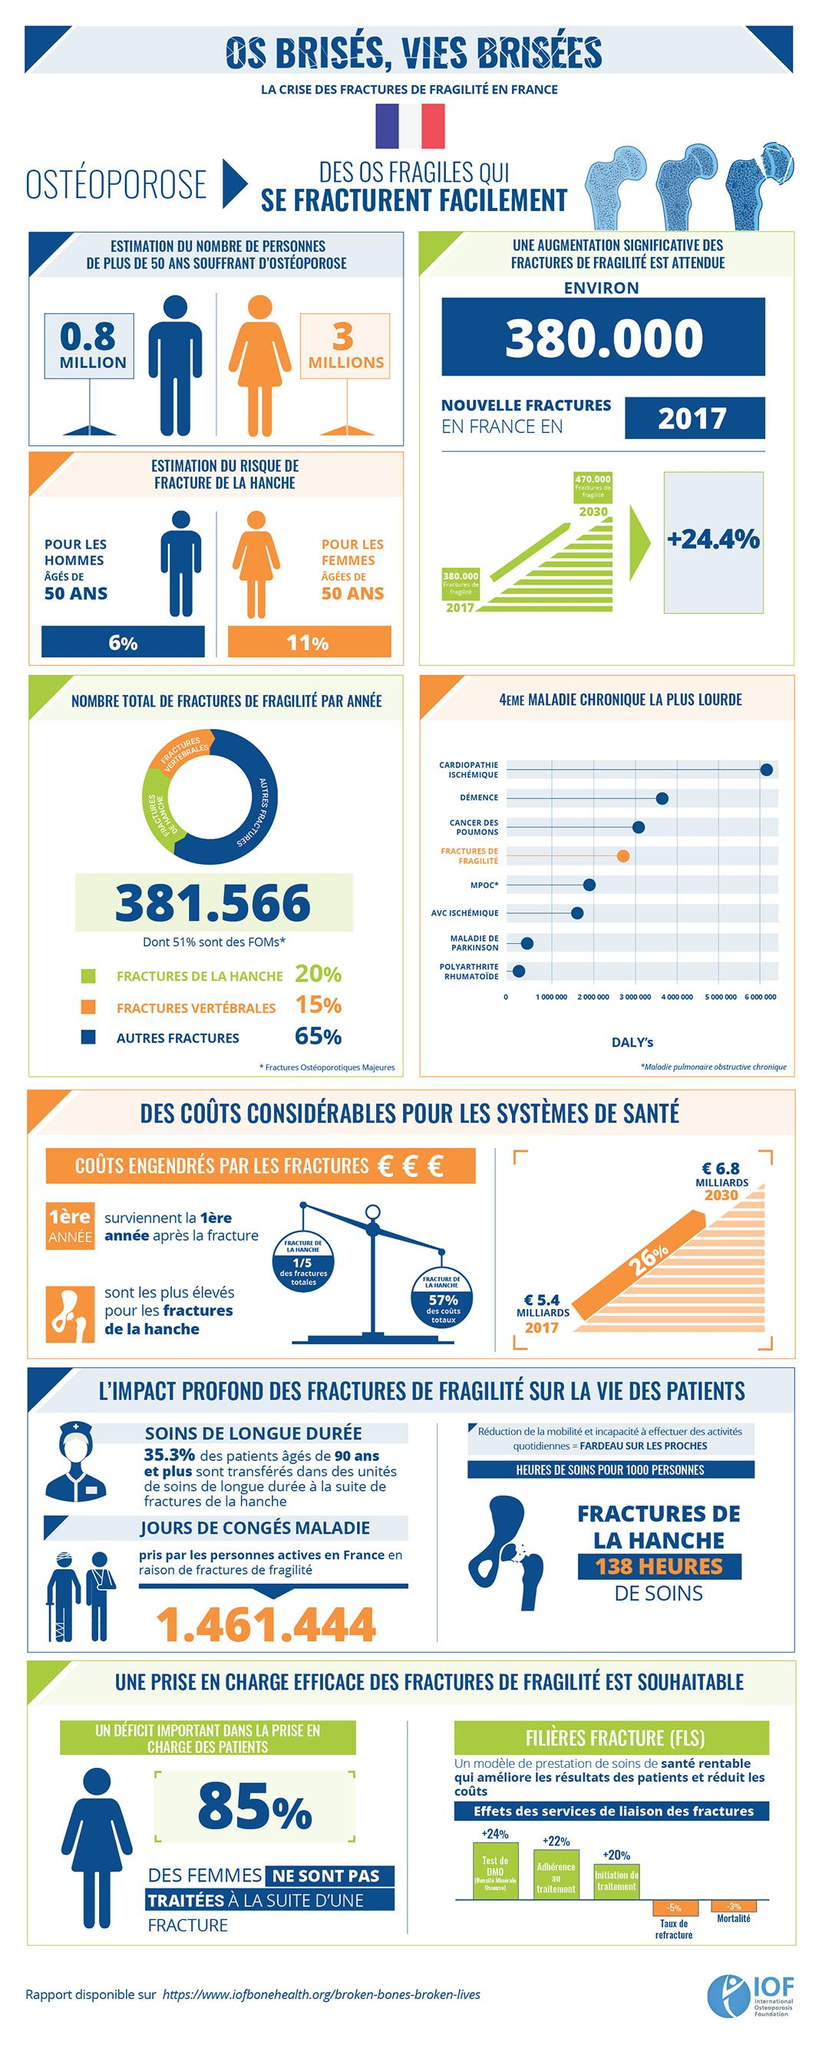List a handful of essential elements in this visual. This collection displays three images featuring females. 